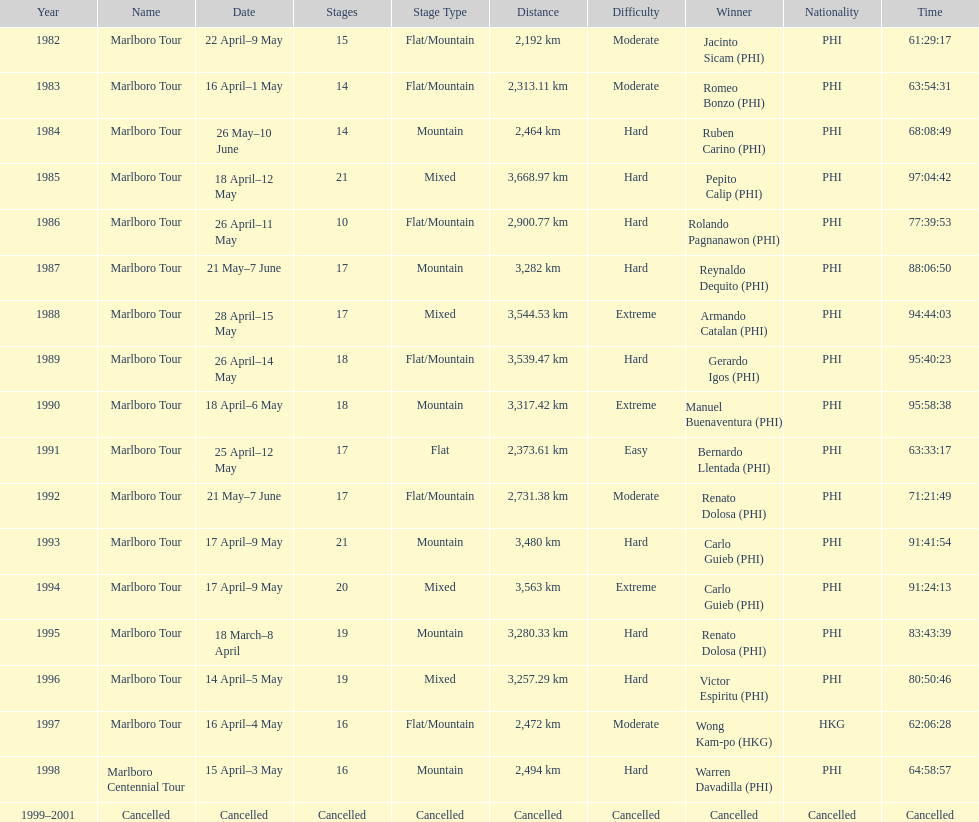Who is listed below romeo bonzo? Ruben Carino (PHI). 